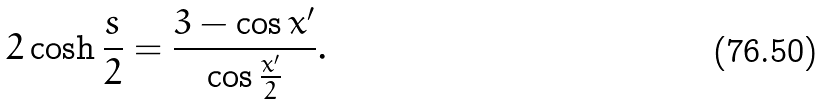Convert formula to latex. <formula><loc_0><loc_0><loc_500><loc_500>2 \cosh \frac { s } { 2 } = \frac { 3 - \cos x ^ { \prime } } { \cos \frac { x ^ { \prime } } { 2 } } .</formula> 